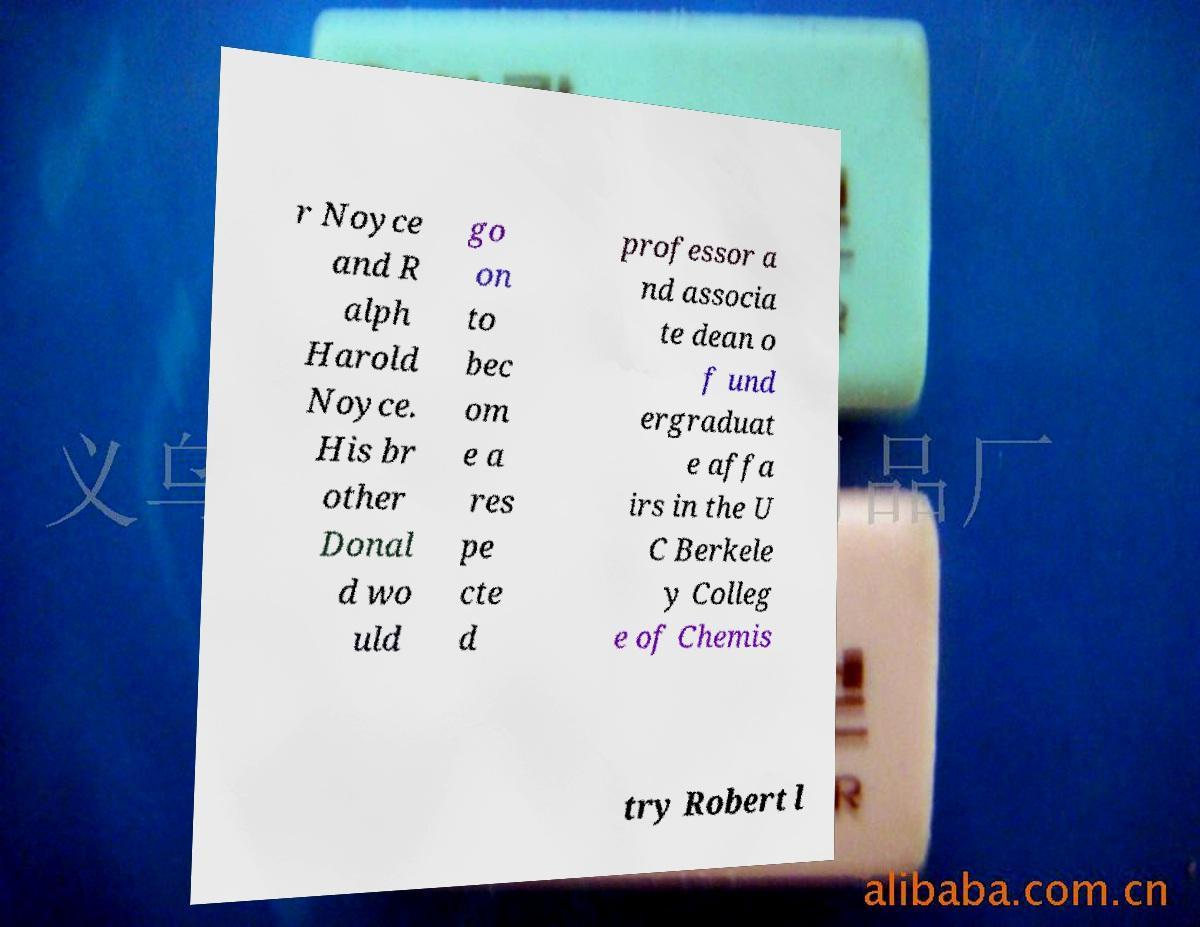Please read and relay the text visible in this image. What does it say? r Noyce and R alph Harold Noyce. His br other Donal d wo uld go on to bec om e a res pe cte d professor a nd associa te dean o f und ergraduat e affa irs in the U C Berkele y Colleg e of Chemis try Robert l 